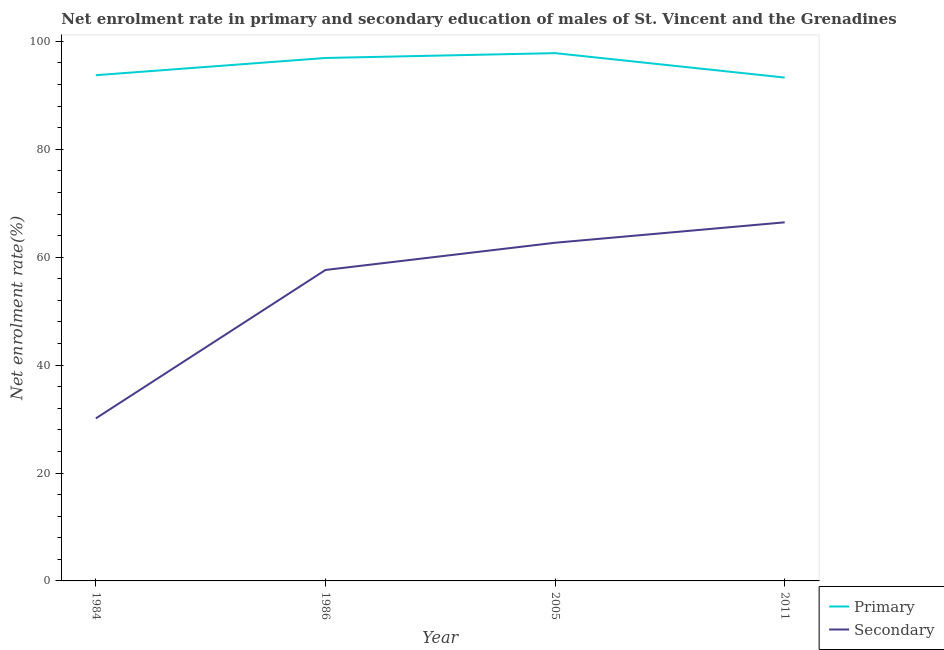How many different coloured lines are there?
Your response must be concise. 2. Is the number of lines equal to the number of legend labels?
Give a very brief answer. Yes. What is the enrollment rate in primary education in 2011?
Your answer should be very brief. 93.29. Across all years, what is the maximum enrollment rate in primary education?
Make the answer very short. 97.81. Across all years, what is the minimum enrollment rate in secondary education?
Give a very brief answer. 30.12. In which year was the enrollment rate in primary education maximum?
Make the answer very short. 2005. What is the total enrollment rate in primary education in the graph?
Provide a succinct answer. 381.74. What is the difference between the enrollment rate in secondary education in 2005 and that in 2011?
Offer a terse response. -3.78. What is the difference between the enrollment rate in secondary education in 2005 and the enrollment rate in primary education in 2011?
Offer a terse response. -30.61. What is the average enrollment rate in primary education per year?
Your answer should be compact. 95.43. In the year 1984, what is the difference between the enrollment rate in primary education and enrollment rate in secondary education?
Provide a succinct answer. 63.6. In how many years, is the enrollment rate in primary education greater than 28 %?
Provide a succinct answer. 4. What is the ratio of the enrollment rate in primary education in 1984 to that in 2005?
Offer a terse response. 0.96. Is the enrollment rate in primary education in 1986 less than that in 2005?
Provide a succinct answer. Yes. What is the difference between the highest and the second highest enrollment rate in secondary education?
Your response must be concise. 3.78. What is the difference between the highest and the lowest enrollment rate in secondary education?
Offer a very short reply. 36.33. Is the sum of the enrollment rate in secondary education in 1984 and 2011 greater than the maximum enrollment rate in primary education across all years?
Provide a succinct answer. No. Does the enrollment rate in primary education monotonically increase over the years?
Offer a very short reply. No. Is the enrollment rate in secondary education strictly greater than the enrollment rate in primary education over the years?
Ensure brevity in your answer.  No. Is the enrollment rate in secondary education strictly less than the enrollment rate in primary education over the years?
Your response must be concise. Yes. How many lines are there?
Make the answer very short. 2. How many years are there in the graph?
Offer a very short reply. 4. Does the graph contain any zero values?
Make the answer very short. No. Does the graph contain grids?
Your answer should be compact. No. Where does the legend appear in the graph?
Ensure brevity in your answer.  Bottom right. How are the legend labels stacked?
Your answer should be very brief. Vertical. What is the title of the graph?
Give a very brief answer. Net enrolment rate in primary and secondary education of males of St. Vincent and the Grenadines. Does "Drinking water services" appear as one of the legend labels in the graph?
Provide a short and direct response. No. What is the label or title of the Y-axis?
Ensure brevity in your answer.  Net enrolment rate(%). What is the Net enrolment rate(%) in Primary in 1984?
Your answer should be compact. 93.72. What is the Net enrolment rate(%) of Secondary in 1984?
Offer a terse response. 30.12. What is the Net enrolment rate(%) of Primary in 1986?
Keep it short and to the point. 96.92. What is the Net enrolment rate(%) of Secondary in 1986?
Give a very brief answer. 57.63. What is the Net enrolment rate(%) in Primary in 2005?
Offer a terse response. 97.81. What is the Net enrolment rate(%) of Secondary in 2005?
Offer a very short reply. 62.67. What is the Net enrolment rate(%) in Primary in 2011?
Give a very brief answer. 93.29. What is the Net enrolment rate(%) in Secondary in 2011?
Your response must be concise. 66.46. Across all years, what is the maximum Net enrolment rate(%) in Primary?
Ensure brevity in your answer.  97.81. Across all years, what is the maximum Net enrolment rate(%) of Secondary?
Your answer should be compact. 66.46. Across all years, what is the minimum Net enrolment rate(%) of Primary?
Provide a succinct answer. 93.29. Across all years, what is the minimum Net enrolment rate(%) of Secondary?
Ensure brevity in your answer.  30.12. What is the total Net enrolment rate(%) of Primary in the graph?
Give a very brief answer. 381.74. What is the total Net enrolment rate(%) of Secondary in the graph?
Ensure brevity in your answer.  216.88. What is the difference between the Net enrolment rate(%) of Primary in 1984 and that in 1986?
Ensure brevity in your answer.  -3.19. What is the difference between the Net enrolment rate(%) of Secondary in 1984 and that in 1986?
Your answer should be very brief. -27.5. What is the difference between the Net enrolment rate(%) of Primary in 1984 and that in 2005?
Your response must be concise. -4.09. What is the difference between the Net enrolment rate(%) of Secondary in 1984 and that in 2005?
Provide a short and direct response. -32.55. What is the difference between the Net enrolment rate(%) of Primary in 1984 and that in 2011?
Keep it short and to the point. 0.44. What is the difference between the Net enrolment rate(%) of Secondary in 1984 and that in 2011?
Ensure brevity in your answer.  -36.33. What is the difference between the Net enrolment rate(%) in Primary in 1986 and that in 2005?
Offer a terse response. -0.9. What is the difference between the Net enrolment rate(%) in Secondary in 1986 and that in 2005?
Your answer should be very brief. -5.05. What is the difference between the Net enrolment rate(%) in Primary in 1986 and that in 2011?
Offer a terse response. 3.63. What is the difference between the Net enrolment rate(%) of Secondary in 1986 and that in 2011?
Provide a short and direct response. -8.83. What is the difference between the Net enrolment rate(%) in Primary in 2005 and that in 2011?
Offer a very short reply. 4.53. What is the difference between the Net enrolment rate(%) of Secondary in 2005 and that in 2011?
Your answer should be compact. -3.78. What is the difference between the Net enrolment rate(%) of Primary in 1984 and the Net enrolment rate(%) of Secondary in 1986?
Ensure brevity in your answer.  36.1. What is the difference between the Net enrolment rate(%) in Primary in 1984 and the Net enrolment rate(%) in Secondary in 2005?
Your response must be concise. 31.05. What is the difference between the Net enrolment rate(%) in Primary in 1984 and the Net enrolment rate(%) in Secondary in 2011?
Your answer should be compact. 27.27. What is the difference between the Net enrolment rate(%) of Primary in 1986 and the Net enrolment rate(%) of Secondary in 2005?
Your answer should be very brief. 34.24. What is the difference between the Net enrolment rate(%) of Primary in 1986 and the Net enrolment rate(%) of Secondary in 2011?
Provide a short and direct response. 30.46. What is the difference between the Net enrolment rate(%) in Primary in 2005 and the Net enrolment rate(%) in Secondary in 2011?
Your answer should be compact. 31.36. What is the average Net enrolment rate(%) in Primary per year?
Keep it short and to the point. 95.43. What is the average Net enrolment rate(%) of Secondary per year?
Provide a short and direct response. 54.22. In the year 1984, what is the difference between the Net enrolment rate(%) in Primary and Net enrolment rate(%) in Secondary?
Make the answer very short. 63.6. In the year 1986, what is the difference between the Net enrolment rate(%) of Primary and Net enrolment rate(%) of Secondary?
Provide a short and direct response. 39.29. In the year 2005, what is the difference between the Net enrolment rate(%) of Primary and Net enrolment rate(%) of Secondary?
Provide a succinct answer. 35.14. In the year 2011, what is the difference between the Net enrolment rate(%) in Primary and Net enrolment rate(%) in Secondary?
Your answer should be very brief. 26.83. What is the ratio of the Net enrolment rate(%) in Primary in 1984 to that in 1986?
Offer a terse response. 0.97. What is the ratio of the Net enrolment rate(%) in Secondary in 1984 to that in 1986?
Give a very brief answer. 0.52. What is the ratio of the Net enrolment rate(%) of Primary in 1984 to that in 2005?
Your answer should be compact. 0.96. What is the ratio of the Net enrolment rate(%) in Secondary in 1984 to that in 2005?
Give a very brief answer. 0.48. What is the ratio of the Net enrolment rate(%) in Primary in 1984 to that in 2011?
Provide a short and direct response. 1. What is the ratio of the Net enrolment rate(%) in Secondary in 1984 to that in 2011?
Your answer should be very brief. 0.45. What is the ratio of the Net enrolment rate(%) in Secondary in 1986 to that in 2005?
Your answer should be compact. 0.92. What is the ratio of the Net enrolment rate(%) of Primary in 1986 to that in 2011?
Ensure brevity in your answer.  1.04. What is the ratio of the Net enrolment rate(%) in Secondary in 1986 to that in 2011?
Keep it short and to the point. 0.87. What is the ratio of the Net enrolment rate(%) in Primary in 2005 to that in 2011?
Make the answer very short. 1.05. What is the ratio of the Net enrolment rate(%) in Secondary in 2005 to that in 2011?
Give a very brief answer. 0.94. What is the difference between the highest and the second highest Net enrolment rate(%) of Primary?
Your answer should be very brief. 0.9. What is the difference between the highest and the second highest Net enrolment rate(%) of Secondary?
Your response must be concise. 3.78. What is the difference between the highest and the lowest Net enrolment rate(%) of Primary?
Offer a terse response. 4.53. What is the difference between the highest and the lowest Net enrolment rate(%) of Secondary?
Your answer should be compact. 36.33. 